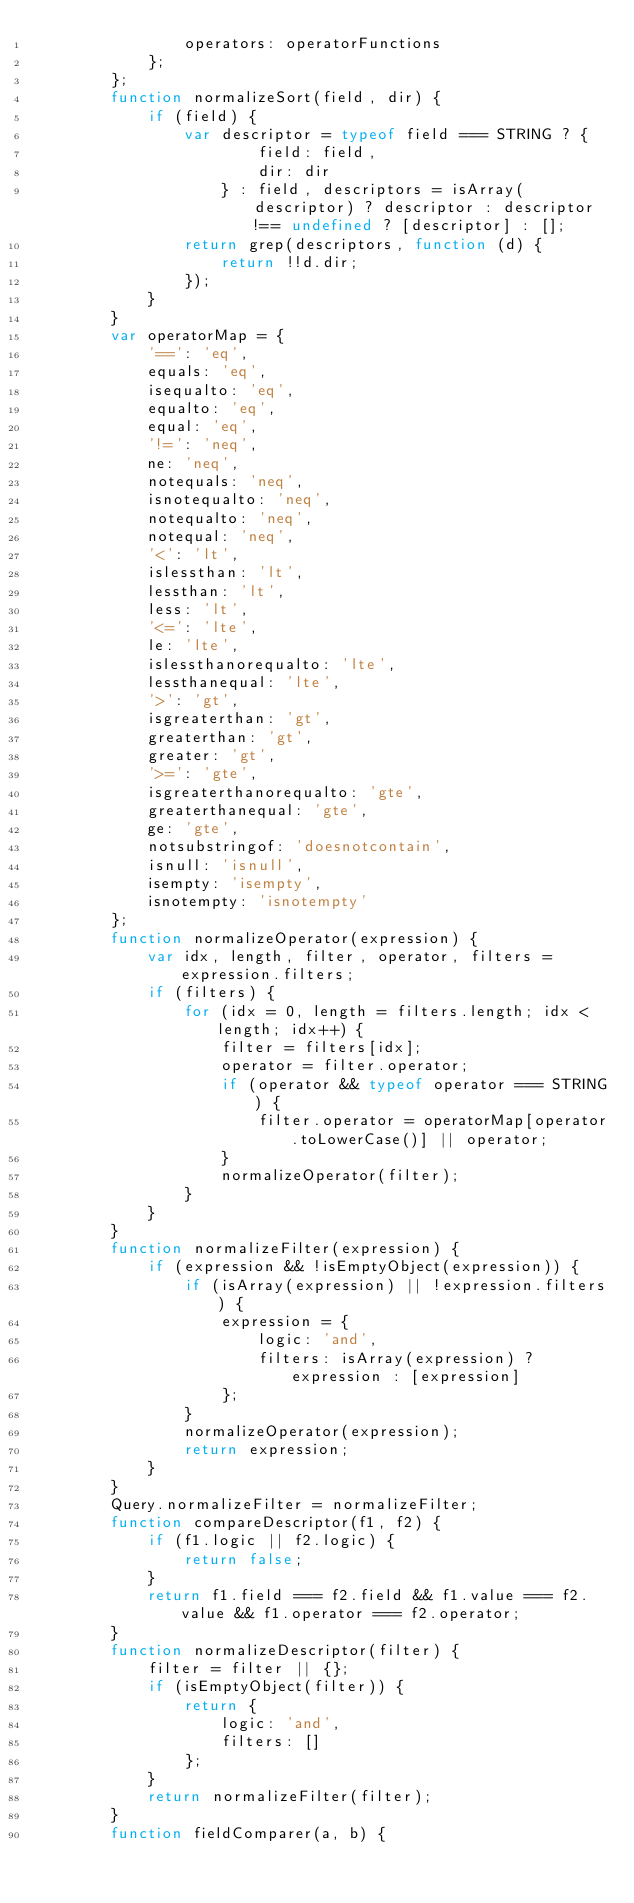Convert code to text. <code><loc_0><loc_0><loc_500><loc_500><_JavaScript_>                operators: operatorFunctions
            };
        };
        function normalizeSort(field, dir) {
            if (field) {
                var descriptor = typeof field === STRING ? {
                        field: field,
                        dir: dir
                    } : field, descriptors = isArray(descriptor) ? descriptor : descriptor !== undefined ? [descriptor] : [];
                return grep(descriptors, function (d) {
                    return !!d.dir;
                });
            }
        }
        var operatorMap = {
            '==': 'eq',
            equals: 'eq',
            isequalto: 'eq',
            equalto: 'eq',
            equal: 'eq',
            '!=': 'neq',
            ne: 'neq',
            notequals: 'neq',
            isnotequalto: 'neq',
            notequalto: 'neq',
            notequal: 'neq',
            '<': 'lt',
            islessthan: 'lt',
            lessthan: 'lt',
            less: 'lt',
            '<=': 'lte',
            le: 'lte',
            islessthanorequalto: 'lte',
            lessthanequal: 'lte',
            '>': 'gt',
            isgreaterthan: 'gt',
            greaterthan: 'gt',
            greater: 'gt',
            '>=': 'gte',
            isgreaterthanorequalto: 'gte',
            greaterthanequal: 'gte',
            ge: 'gte',
            notsubstringof: 'doesnotcontain',
            isnull: 'isnull',
            isempty: 'isempty',
            isnotempty: 'isnotempty'
        };
        function normalizeOperator(expression) {
            var idx, length, filter, operator, filters = expression.filters;
            if (filters) {
                for (idx = 0, length = filters.length; idx < length; idx++) {
                    filter = filters[idx];
                    operator = filter.operator;
                    if (operator && typeof operator === STRING) {
                        filter.operator = operatorMap[operator.toLowerCase()] || operator;
                    }
                    normalizeOperator(filter);
                }
            }
        }
        function normalizeFilter(expression) {
            if (expression && !isEmptyObject(expression)) {
                if (isArray(expression) || !expression.filters) {
                    expression = {
                        logic: 'and',
                        filters: isArray(expression) ? expression : [expression]
                    };
                }
                normalizeOperator(expression);
                return expression;
            }
        }
        Query.normalizeFilter = normalizeFilter;
        function compareDescriptor(f1, f2) {
            if (f1.logic || f2.logic) {
                return false;
            }
            return f1.field === f2.field && f1.value === f2.value && f1.operator === f2.operator;
        }
        function normalizeDescriptor(filter) {
            filter = filter || {};
            if (isEmptyObject(filter)) {
                return {
                    logic: 'and',
                    filters: []
                };
            }
            return normalizeFilter(filter);
        }
        function fieldComparer(a, b) {</code> 